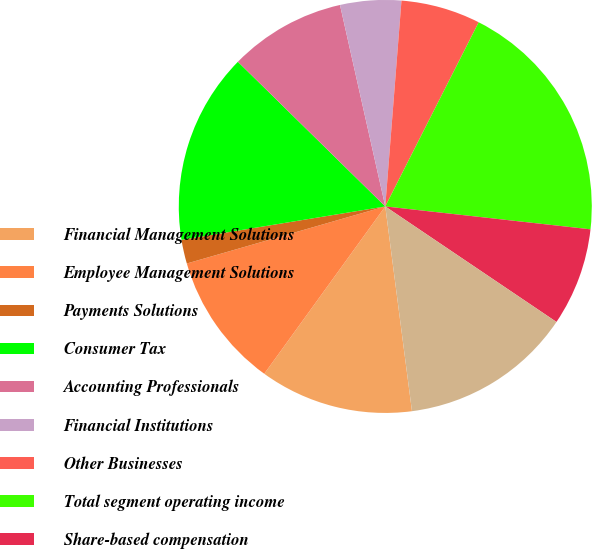Convert chart. <chart><loc_0><loc_0><loc_500><loc_500><pie_chart><fcel>Financial Management Solutions<fcel>Employee Management Solutions<fcel>Payments Solutions<fcel>Consumer Tax<fcel>Accounting Professionals<fcel>Financial Institutions<fcel>Other Businesses<fcel>Total segment operating income<fcel>Share-based compensation<fcel>Other common expenses<nl><fcel>12.03%<fcel>10.58%<fcel>1.87%<fcel>14.94%<fcel>9.13%<fcel>4.77%<fcel>6.22%<fcel>19.3%<fcel>7.68%<fcel>13.49%<nl></chart> 